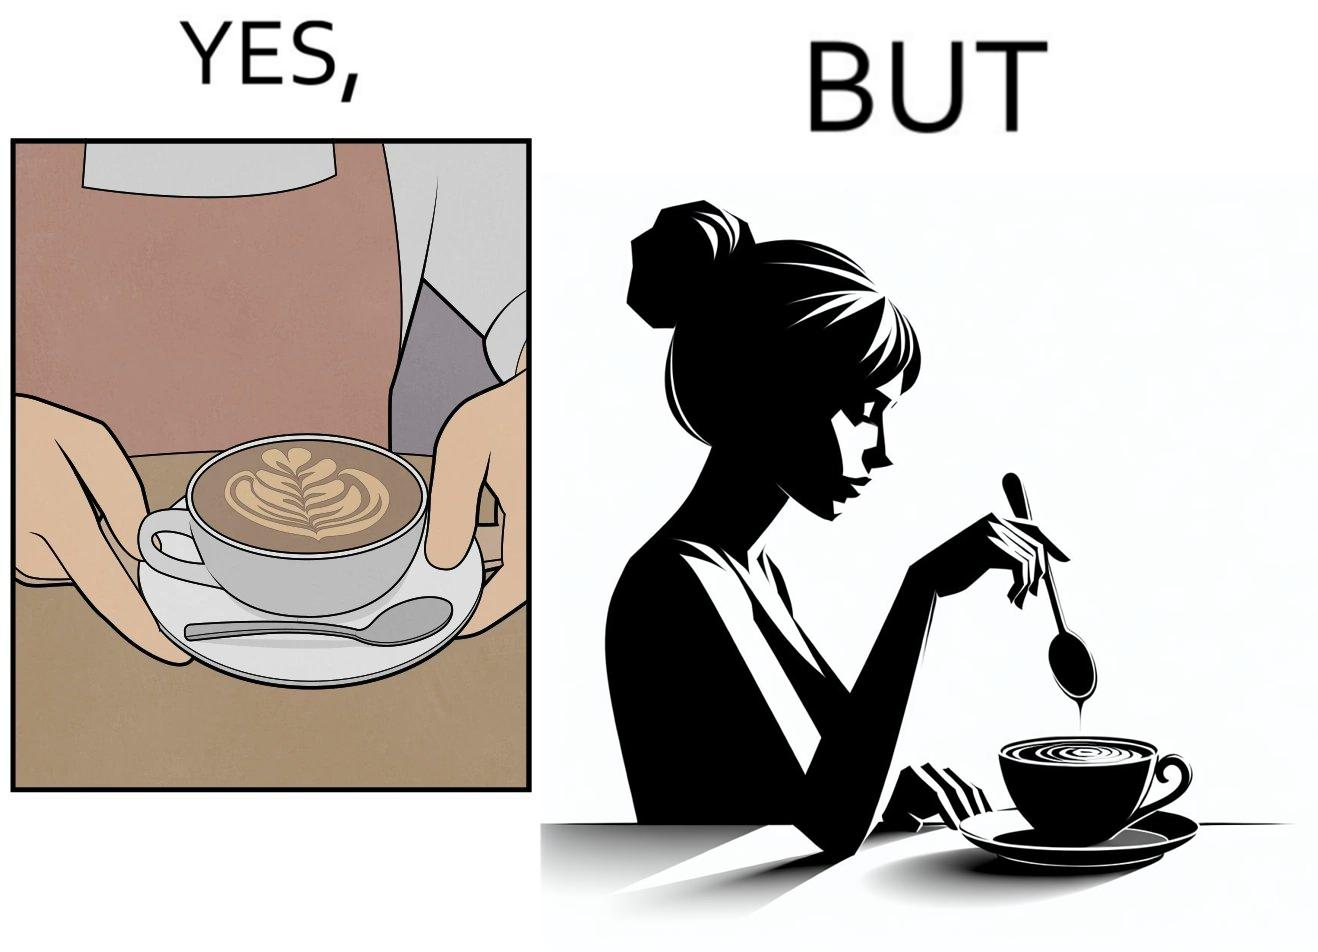Does this image contain satire or humor? Yes, this image is satirical. 